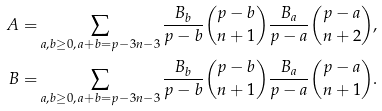<formula> <loc_0><loc_0><loc_500><loc_500>A = & \sum _ { a , b \geq 0 , \, a + b = p - 3 n - 3 } \frac { B _ { b } } { p - b } { p - b \choose n + 1 } \frac { B _ { a } } { p - a } { p - a \choose n + 2 } , \\ B = & \sum _ { a , b \geq 0 , \, a + b = p - 3 n - 3 } \frac { B _ { b } } { p - b } { p - b \choose n + 1 } \frac { B _ { a } } { p - a } { p - a \choose n + 1 } .</formula> 